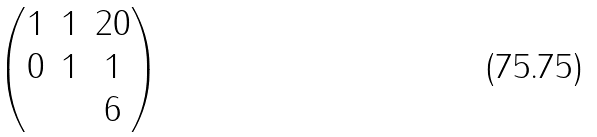<formula> <loc_0><loc_0><loc_500><loc_500>\begin{pmatrix} 1 & 1 & 2 0 \\ 0 & 1 & 1 \\ & & 6 \end{pmatrix}</formula> 